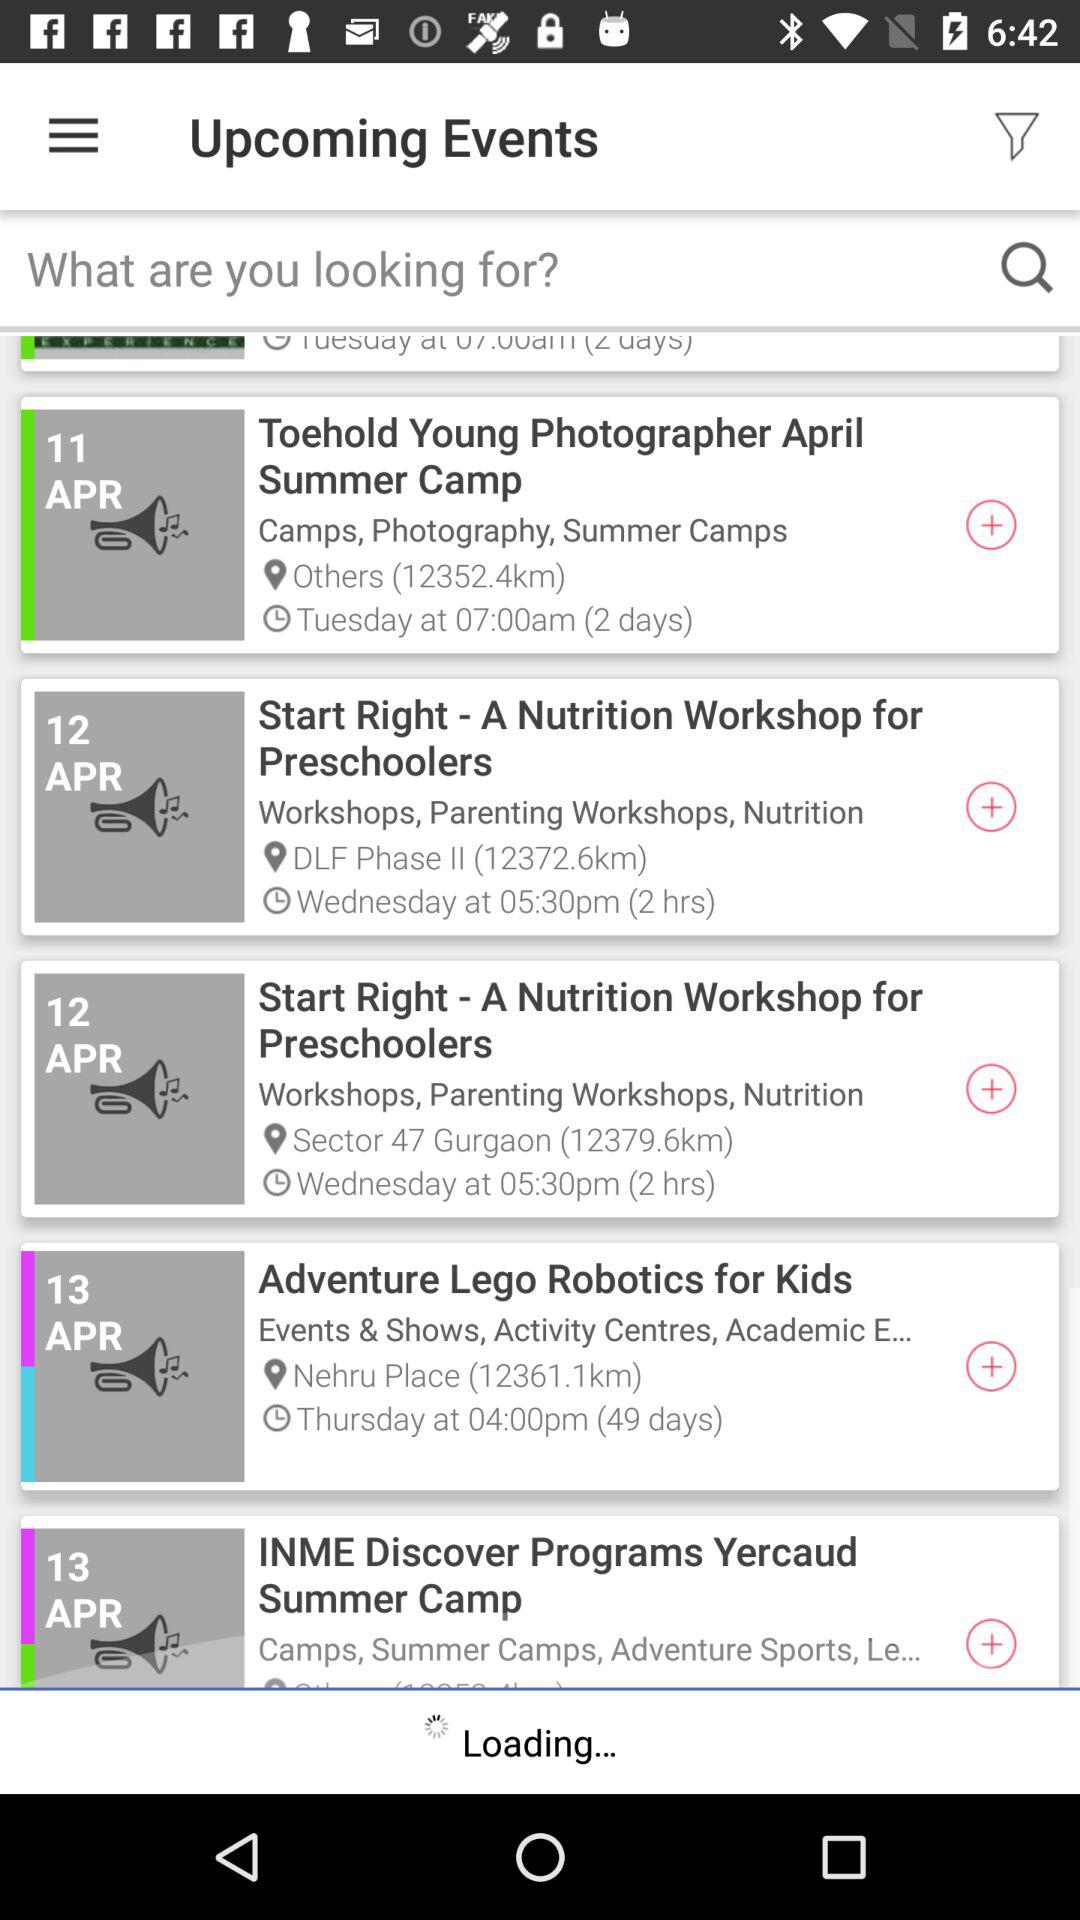At what time will the event "Adventure Lego Robotics for Kids" start? It will start at 4:00 pm. 